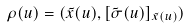<formula> <loc_0><loc_0><loc_500><loc_500>\rho ( u ) = ( \tilde { x } ( u ) , [ \tilde { \sigma } ( u ) ] _ { \tilde { x } ( u ) } )</formula> 